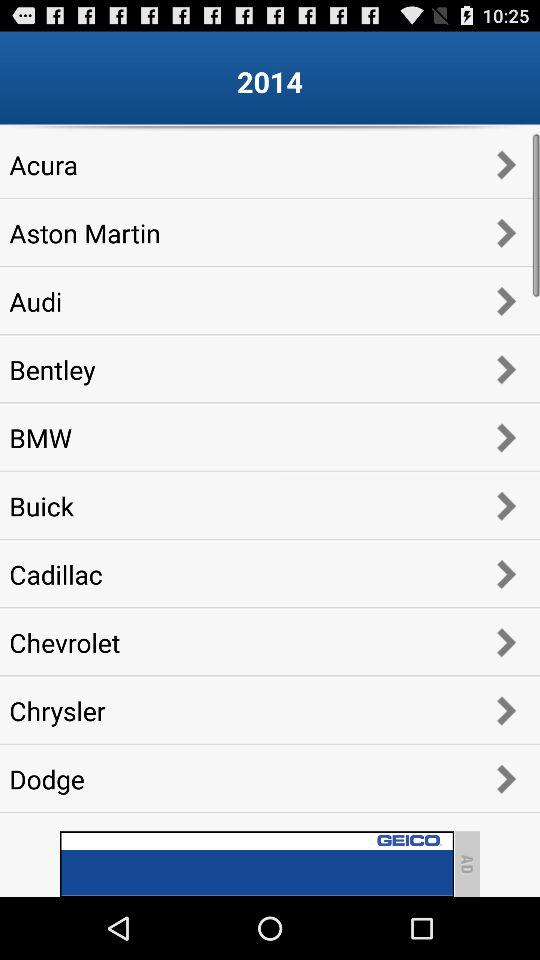What is the mentioned year? The mentioned year is 2014. 